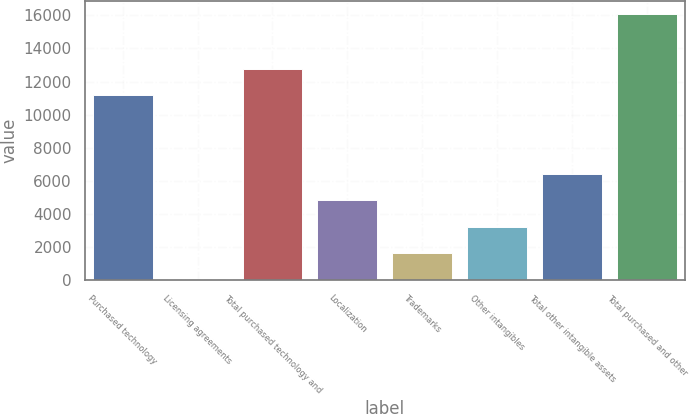Convert chart to OTSL. <chart><loc_0><loc_0><loc_500><loc_500><bar_chart><fcel>Purchased technology<fcel>Licensing agreements<fcel>Total purchased technology and<fcel>Localization<fcel>Trademarks<fcel>Other intangibles<fcel>Total other intangible assets<fcel>Total purchased and other<nl><fcel>11171<fcel>21<fcel>12775.6<fcel>4834.8<fcel>1625.6<fcel>3230.2<fcel>6439.4<fcel>16067<nl></chart> 